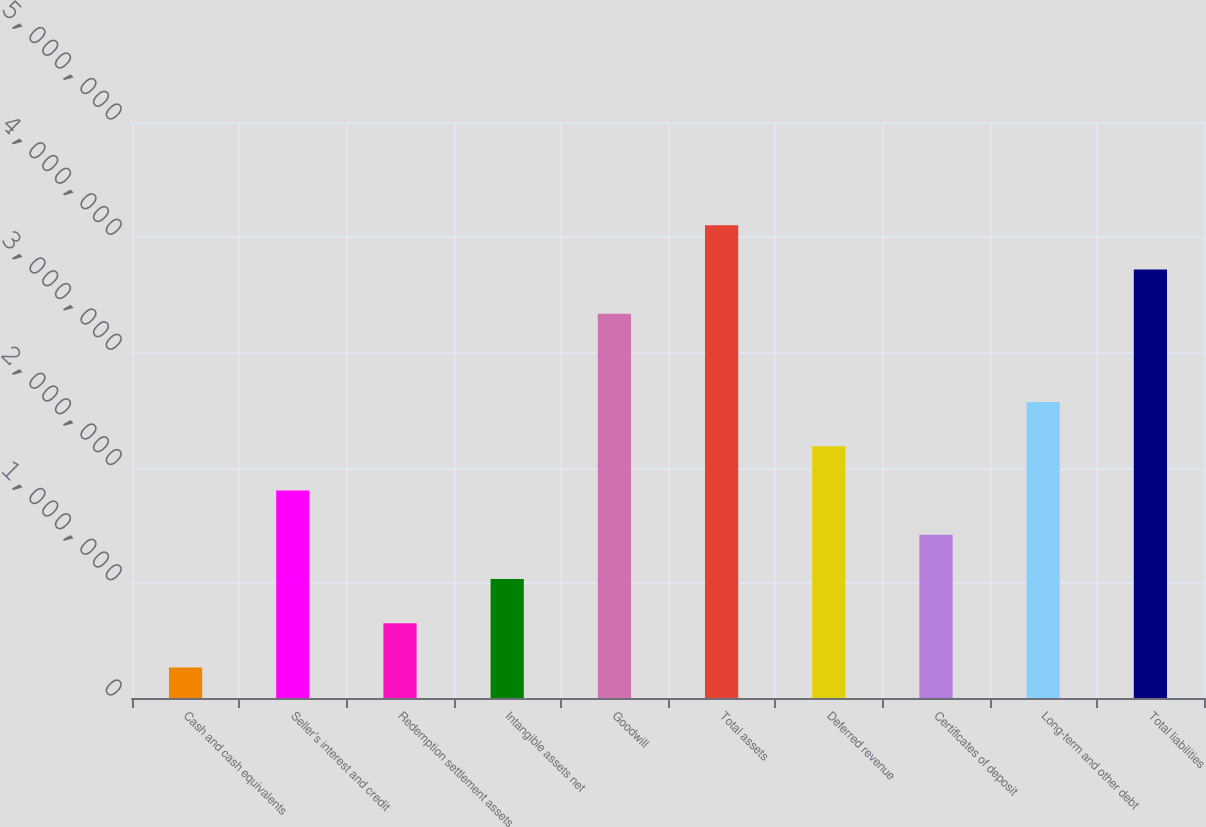Convert chart to OTSL. <chart><loc_0><loc_0><loc_500><loc_500><bar_chart><fcel>Cash and cash equivalents<fcel>Seller's interest and credit<fcel>Redemption settlement assets<fcel>Intangible assets net<fcel>Goodwill<fcel>Total assets<fcel>Deferred revenue<fcel>Certificates of deposit<fcel>Long-term and other debt<fcel>Total liabilities<nl><fcel>265839<fcel>1.80094e+06<fcel>649614<fcel>1.03339e+06<fcel>3.33604e+06<fcel>4.10359e+06<fcel>2.18472e+06<fcel>1.41717e+06<fcel>2.56849e+06<fcel>3.71982e+06<nl></chart> 